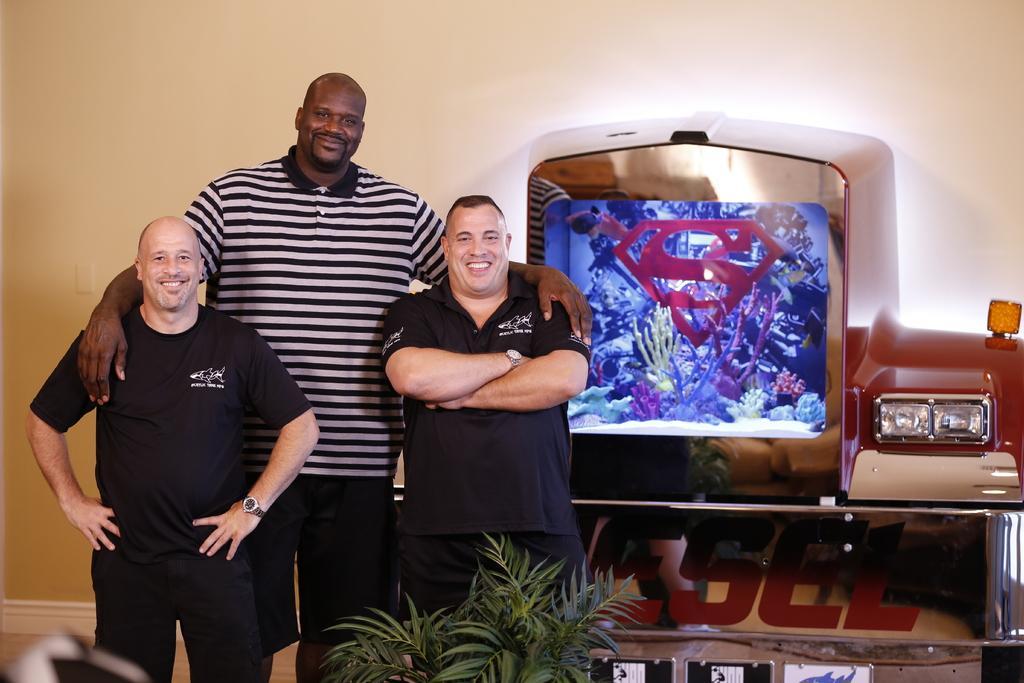Please provide a concise description of this image. In this image I can see three persons are standing and I can also see smile on their faces. On the right side of this image I can see an aquarium and few lights. On the bottom side of this image I can see a plant and I can also see something is written on the bottom right side. 